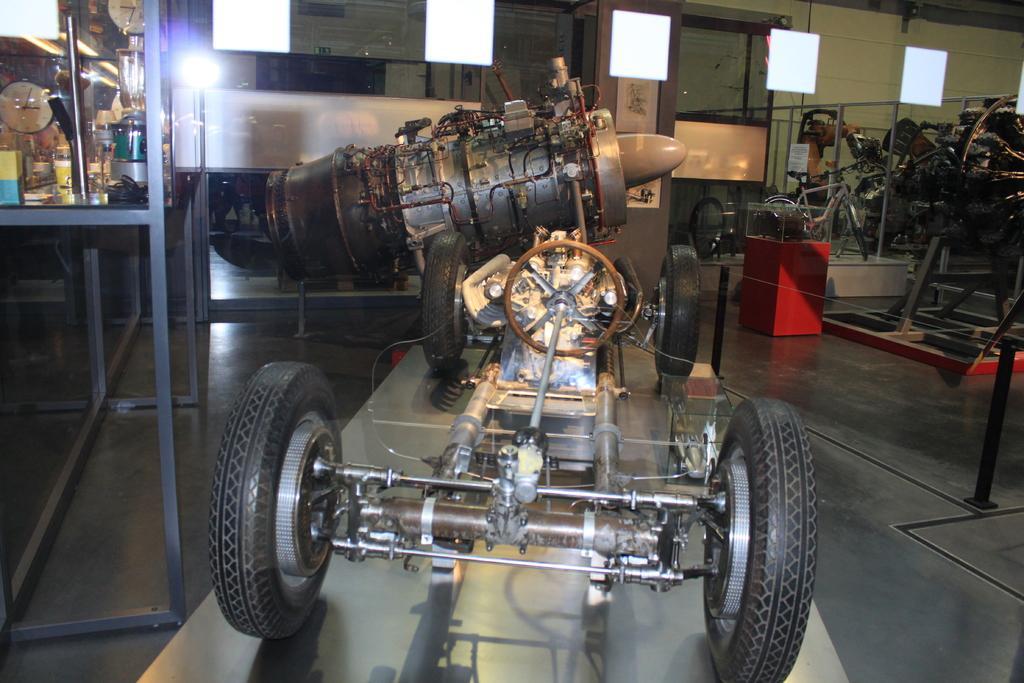Describe this image in one or two sentences. In the foreground of the picture there is a table, on the table there is a machine. On the right there are different machines. On the left in the closet there are few machines. In the background there are glasses and other object. 